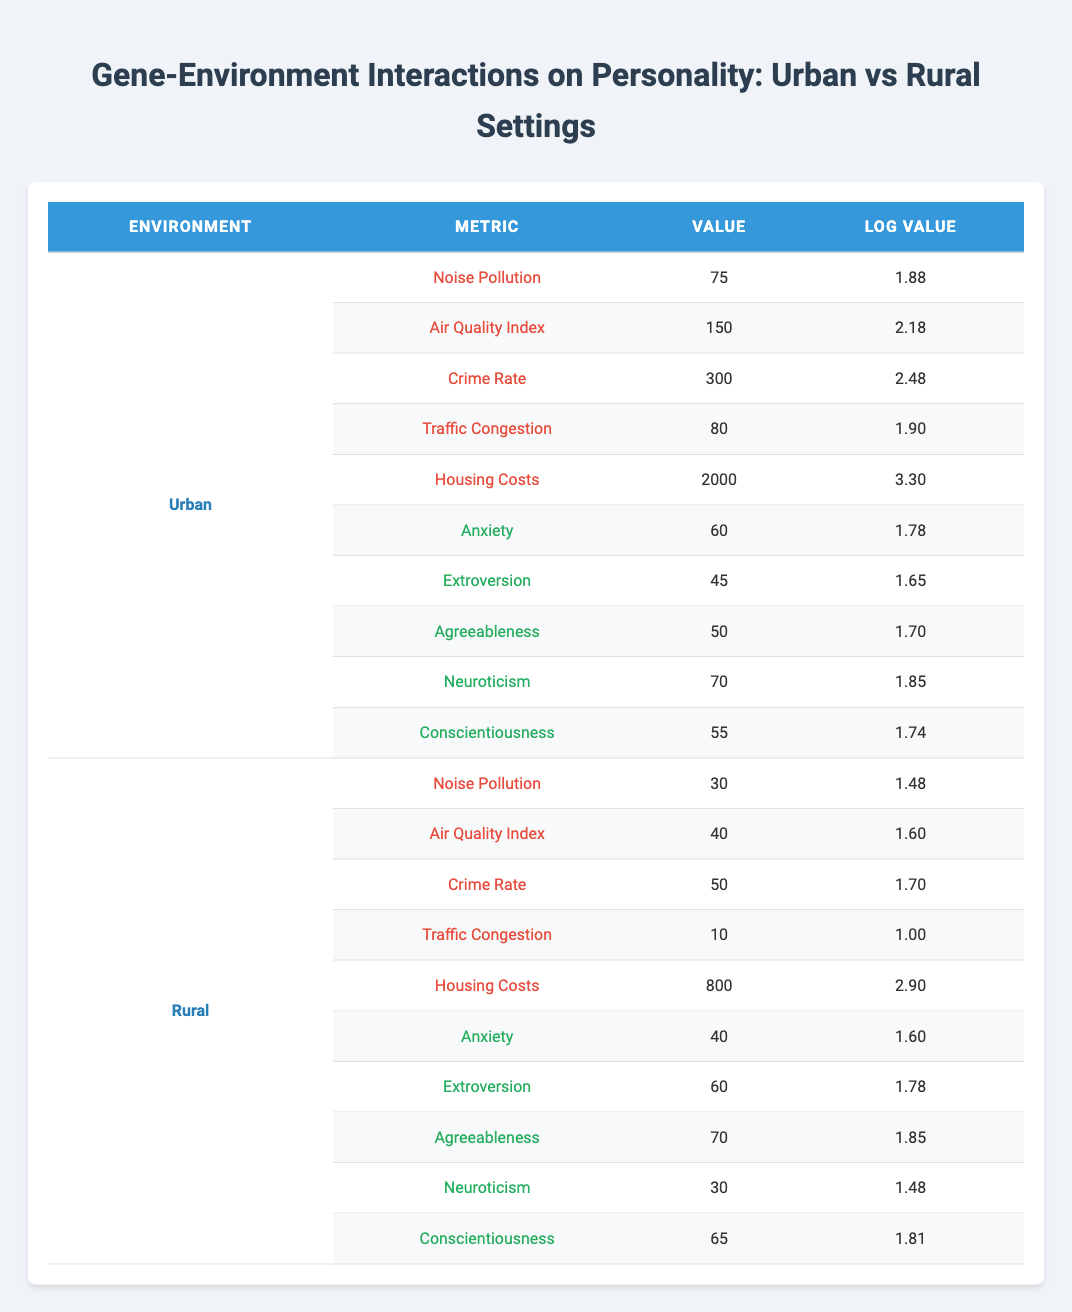What is the value for crime rate in urban settings? The table lists the crime rate under the Urban environment, showing a value of 300.
Answer: 300 What is the log value for housing costs in rural settings? The table shows the value for housing costs in the Rural environment as 800, with a corresponding log value of 2.90.
Answer: 2.90 Is the anxiety level higher in urban or rural settings? The anxiety level in the Urban environment is 60, while in the Rural environment it is 40. Therefore, anxiety is higher in urban settings.
Answer: Yes What is the difference in the extroversion scores between urban and rural environments? The extroversion score for Urban is 45 and for Rural is 60. The difference is calculated as 60 - 45 = 15.
Answer: 15 What is the average level of agreeableness across both environments? The agreeableness score is 50 in Urban and 70 in Rural. Summing these gives 50 + 70 = 120. Dividing by 2 (number of environments) gives an average of 120 / 2 = 60.
Answer: 60 Which personality metric is the lowest in urban environments? The lowest personality metric in Urban is Extroversion, which has a score of 45.
Answer: 45 Is the traffic congestion value higher in urban or rural settings? The traffic congestion value for Urban is 80, while for Rural it is 10, indicating that traffic congestion is higher in urban settings.
Answer: Yes What is the total value of noise pollution and crime rate in rural environments? The noise pollution value in Rural is 30 and the crime rate is 50. Adding these two gives 30 + 50 = 80.
Answer: 80 What is the highest stressor value in urban settings? The stressor values in Urban are noise pollution (75), air quality index (150), crime rate (300), traffic congestion (80), and housing costs (2000). The highest value is for housing costs, which is 2000.
Answer: 2000 